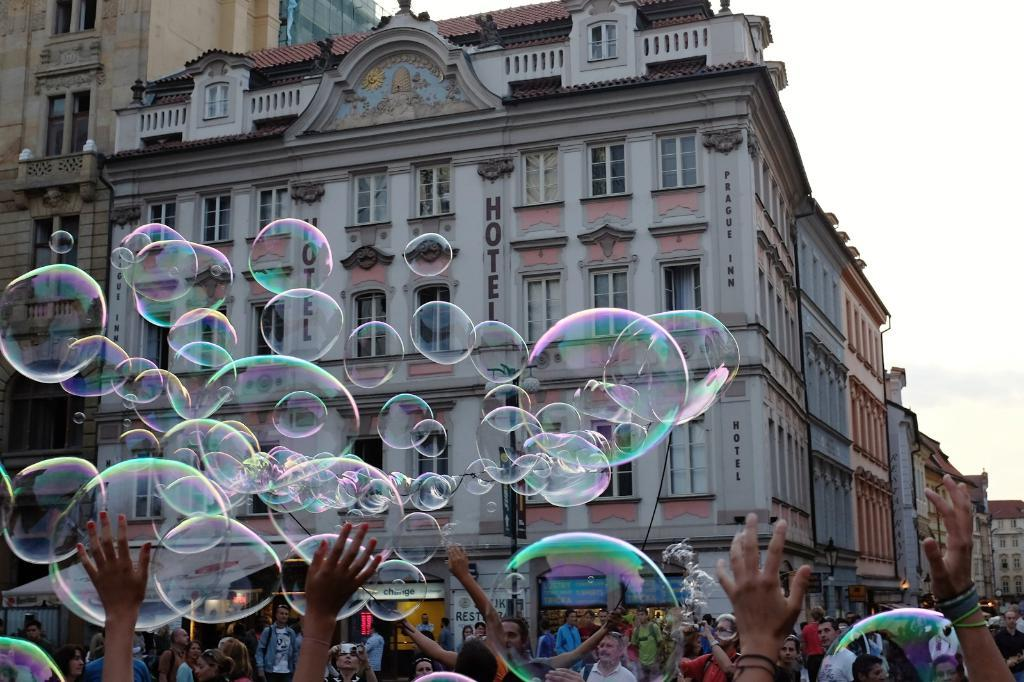What type of structures are visible in the image? There are buildings with windows in the image. What are the people in the image doing? There are groups of people standing in the image. What is flying in the image? Soap bubbles are flying in the image. What is visible in the background of the image? The sky is visible in the image. Where is the nest of the bird in the image? There is no bird or nest present in the image. What type of game are the people playing in the image? There is no game being played in the image; the people are simply standing. 